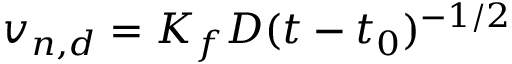Convert formula to latex. <formula><loc_0><loc_0><loc_500><loc_500>v _ { n , d } = K _ { f } D ( t - t _ { 0 } ) ^ { - 1 / 2 }</formula> 